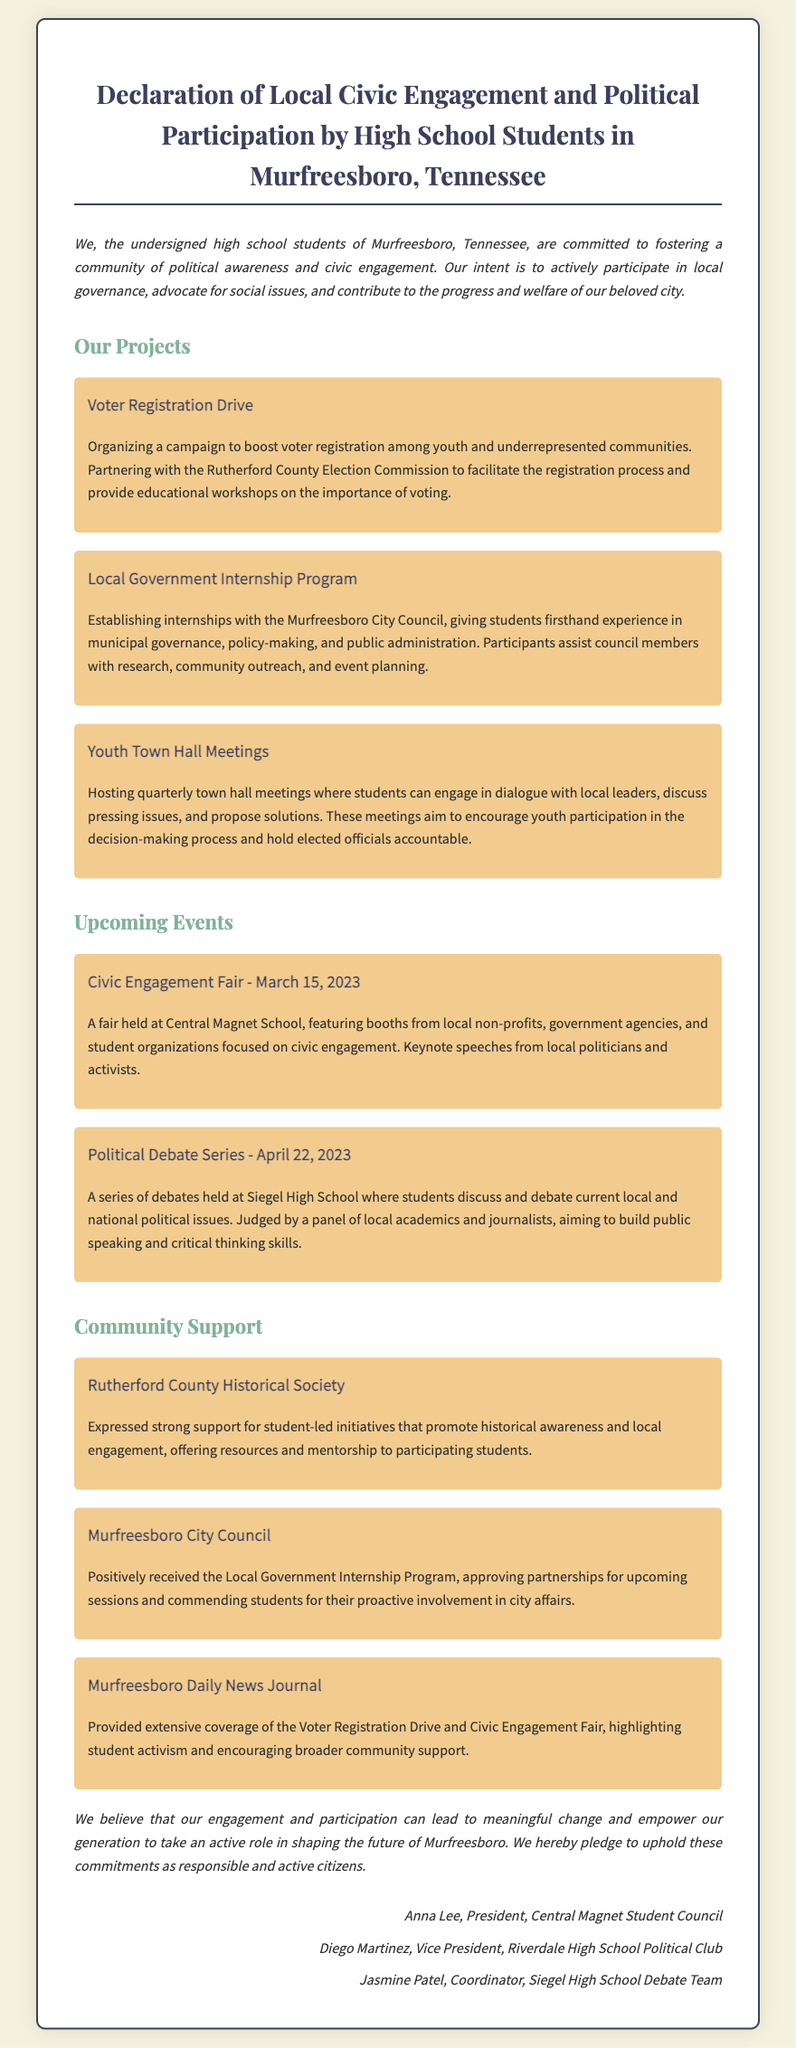What is the title of the document? The title of the document is clearly stated at the top, indicating its main subject.
Answer: Declaration of Local Civic Engagement and Political Participation by High School Students in Murfreesboro, Tennessee What date is the Civic Engagement Fair scheduled? The date for the Civic Engagement Fair is specified in the events section.
Answer: March 15, 2023 Who is the President of the Central Magnet Student Council? The document includes signatures with titles, identifying individuals and their roles.
Answer: Anna Lee What is one of the projects mentioned in the document? The document lists various projects under the section titled "Our Projects."
Answer: Voter Registration Drive How did the Murfreesboro Daily News Journal respond to the initiatives? The response section includes feedback from local organizations regarding the student initiatives.
Answer: Provided extensive coverage of the Voter Registration Drive and Civic Engagement Fair What type of meetings are students hosting quarterly? The document specifies the type of meetings intended for community engagement and discussion.
Answer: Youth Town Hall Meetings Which organization expressed support for student-led initiatives? The document mentions various entities that offered support for the projects.
Answer: Rutherford County Historical Society What is the purpose of the Local Government Internship Program? The document outlines the objectives and activities related to the internship program.
Answer: Experience in municipal governance, policy-making, and public administration 